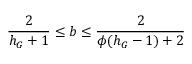Convert formula to latex. <formula><loc_0><loc_0><loc_500><loc_500>\frac { 2 } { h _ { G } + 1 } \leq b \leq \frac { 2 } { \phi ( h _ { G } - 1 ) + 2 }</formula> 